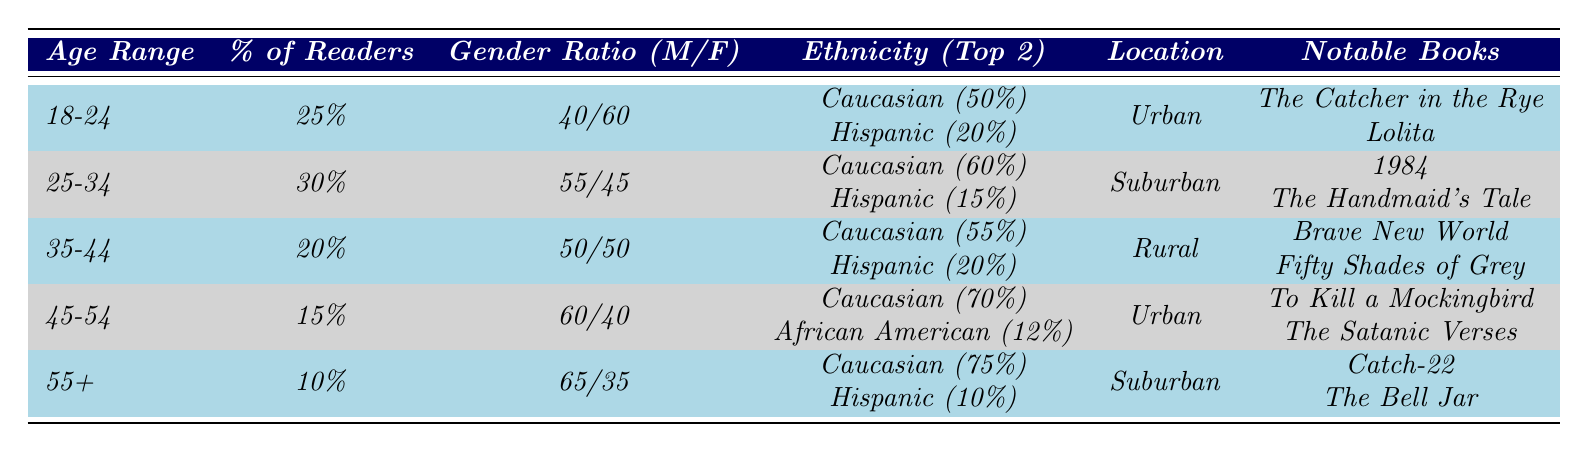What percentage of readers engage with controversial books in the 25-34 age range? The table states that the percentage of readers in the 25-34 age range is 30%.
Answer: 30% Which age range has the highest percentage of readers engaging with controversial books? The 25-34 age range has the highest percentage at 30%.
Answer: 25-34 Is the gender ratio for the 45-54 age range skewed towards males or females? The gender ratio for the 45-54 age range is 60/40, indicating it is skewed towards males.
Answer: Males How many notable controversial books are mentioned for readers aged 18-24? There are two notable controversial books listed for the 18-24 age range: "The Catcher in the Rye" and "Lolita."
Answer: 2 What is the average percentage of readers across all age ranges? To find the average, we add the percentages (25 + 30 + 20 + 15 + 10 = 100) and divide by the number of age ranges (5). Thus, the average is 100/5 = 20%.
Answer: 20% Which age range has the least representation among readers engaging with controversial books? The 55+ age range has the least representation, with only 10% of readers.
Answer: 55+ Are there more females than males reading controversial books in the 35-44 age range? The gender ratio for the 35-44 age range is 50/50, meaning there are equal numbers of males and females.
Answer: No What is the largest ethnic group among readers aged 45-54? The largest ethnic group among readers aged 45-54 is Caucasian, which makes up 70% of the demographic.
Answer: Caucasian Which locations are associated with readers aged 25-34 and 45-54? Readers aged 25-34 are located in Suburban areas, while those aged 45-54 are in Urban areas.
Answer: Suburban and Urban If we combine the percentages of readers aged 18-24 and 35-44, what percentage do we get? The percentages of readers aged 18-24 (25%) and 35-44 (20%) sum to 45%.
Answer: 45% 